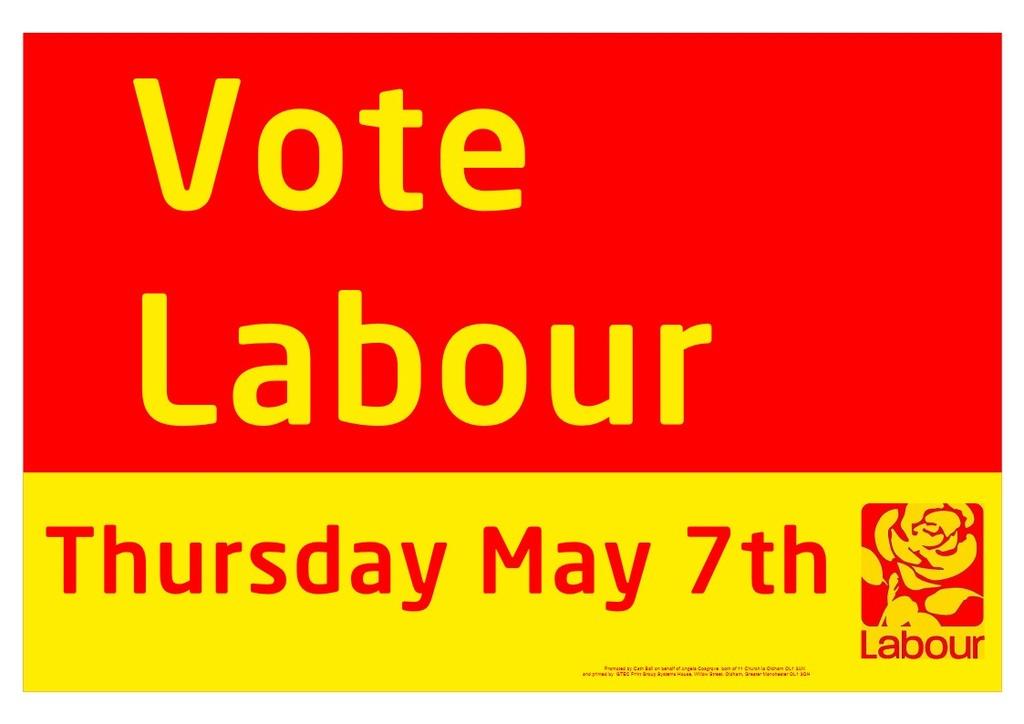What is the date of the vote?
Make the answer very short. May 7th. What should you vote?
Keep it short and to the point. Labour. 